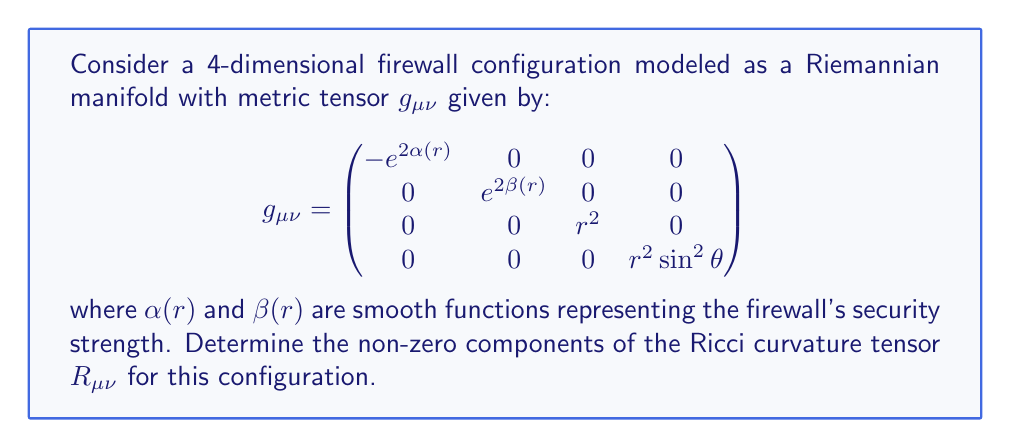Teach me how to tackle this problem. To determine the Ricci curvature tensor, we need to follow these steps:

1) First, calculate the Christoffel symbols $\Gamma^{\lambda}_{\mu\nu}$ using:

   $$\Gamma^{\lambda}_{\mu\nu} = \frac{1}{2}g^{\lambda\sigma}(\partial_\mu g_{\nu\sigma} + \partial_\nu g_{\mu\sigma} - \partial_\sigma g_{\mu\nu})$$

2) Then, calculate the Riemann curvature tensor $R^{\rho}_{\sigma\mu\nu}$ using:

   $$R^{\rho}_{\sigma\mu\nu} = \partial_\mu\Gamma^{\rho}_{\nu\sigma} - \partial_\nu\Gamma^{\rho}_{\mu\sigma} + \Gamma^{\rho}_{\mu\lambda}\Gamma^{\lambda}_{\nu\sigma} - \Gamma^{\rho}_{\nu\lambda}\Gamma^{\lambda}_{\mu\sigma}$$

3) Finally, contract the Riemann tensor to get the Ricci tensor:

   $$R_{\mu\nu} = R^{\lambda}_{\mu\lambda\nu}$$

For this specific metric, due to its diagonal nature and dependence only on $r$, many components will be zero. The non-zero components are:

$$R_{00} = e^{2(\alpha-\beta)}[\alpha'' + \alpha'(\alpha' - \beta') + \frac{2\alpha'}{r}]$$

$$R_{11} = -\alpha'' - \alpha'(\alpha' - \beta') + \frac{2\beta'}{r}$$

$$R_{22} = e^{-2\beta}[1 + r(\beta' - \alpha')] - 1$$

$$R_{33} = R_{22}\sin^2\theta$$

Where $'$ denotes differentiation with respect to $r$.
Answer: $R_{00} = e^{2(\alpha-\beta)}[\alpha'' + \alpha'(\alpha' - \beta') + \frac{2\alpha'}{r}]$
$R_{11} = -\alpha'' - \alpha'(\alpha' - \beta') + \frac{2\beta'}{r}$
$R_{22} = e^{-2\beta}[1 + r(\beta' - \alpha')] - 1$
$R_{33} = R_{22}\sin^2\theta$ 